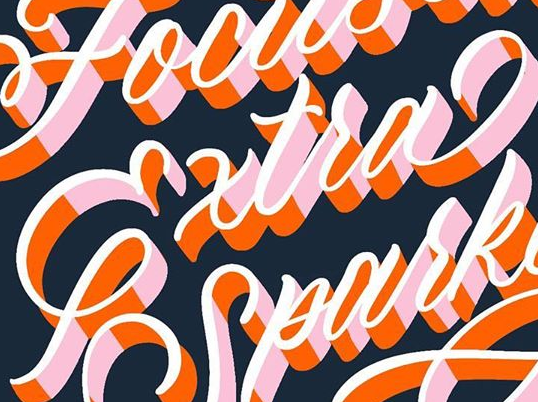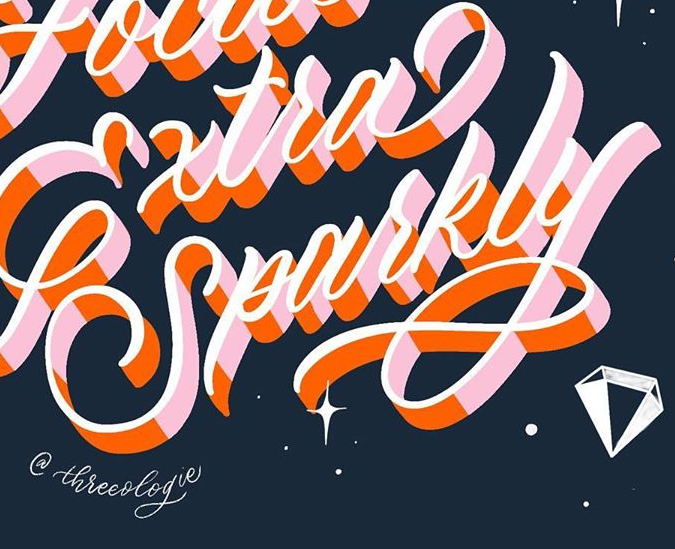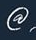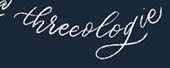Read the text content from these images in order, separated by a semicolon. Extra; Sparkly; @; threeologie 